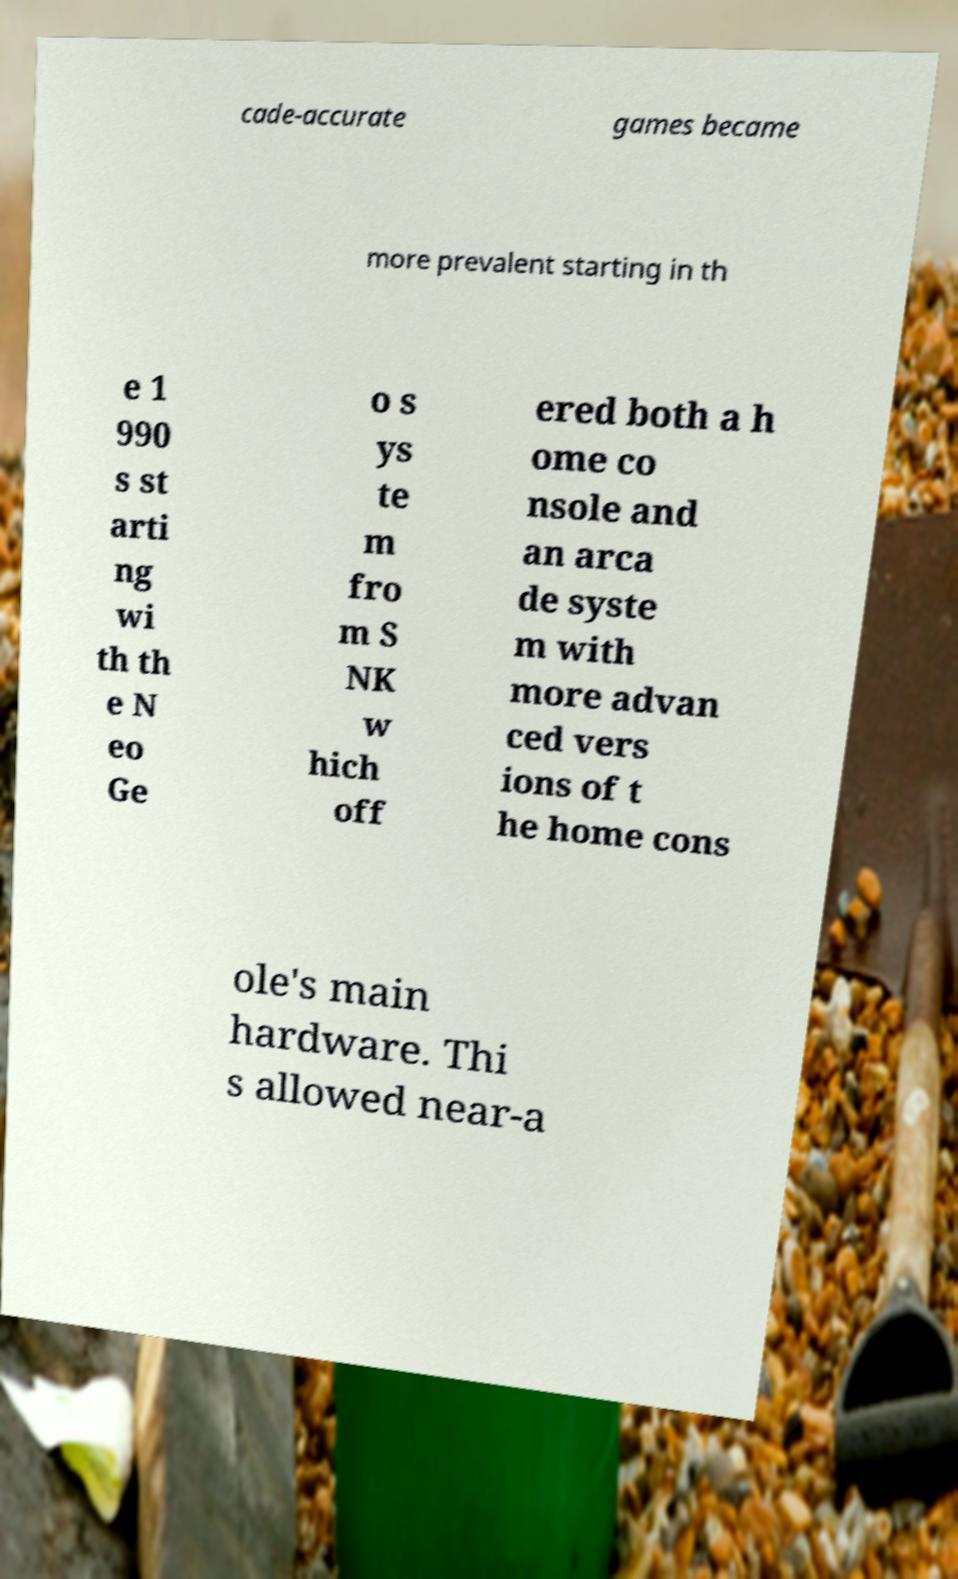Can you read and provide the text displayed in the image?This photo seems to have some interesting text. Can you extract and type it out for me? cade-accurate games became more prevalent starting in th e 1 990 s st arti ng wi th th e N eo Ge o s ys te m fro m S NK w hich off ered both a h ome co nsole and an arca de syste m with more advan ced vers ions of t he home cons ole's main hardware. Thi s allowed near-a 